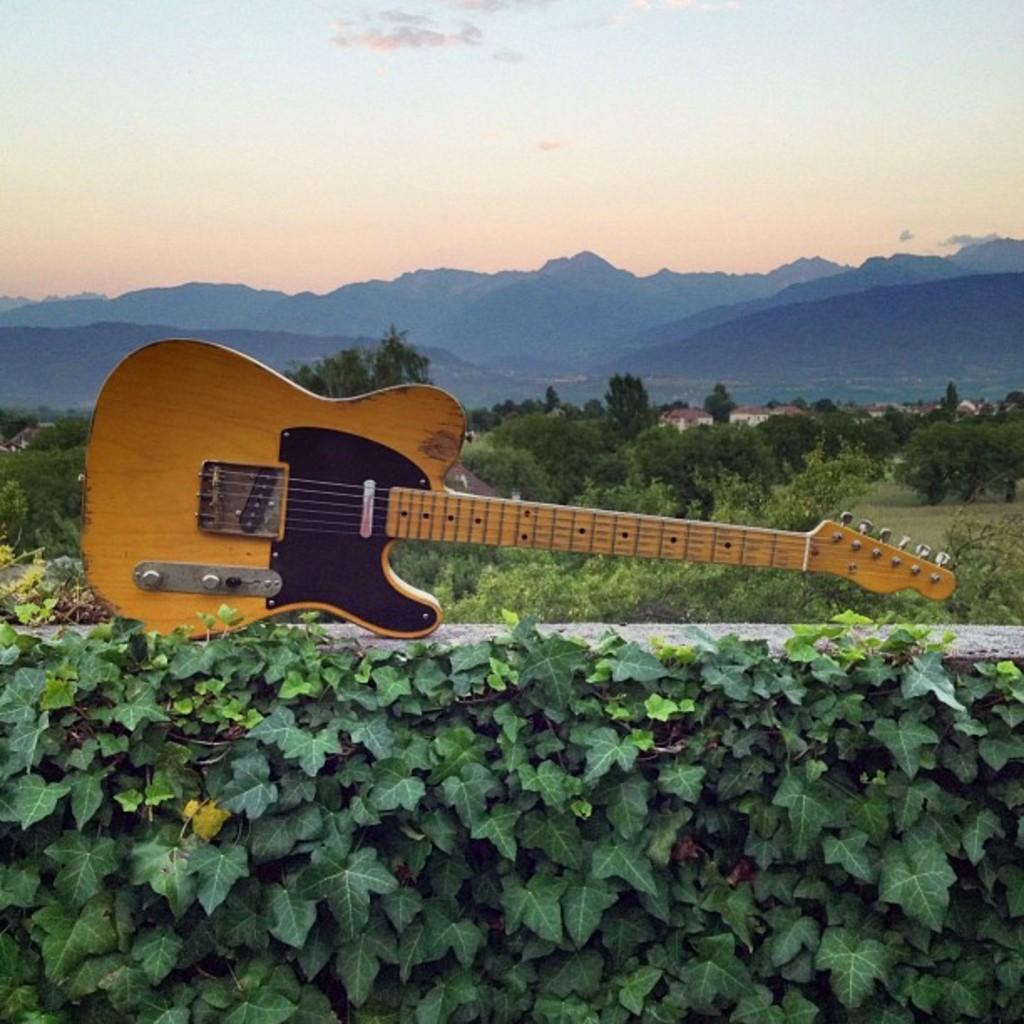What is the main object in the image? There is a guitar in the image. What can be seen in the background of the image? There are trees, mountains, and the sky visible in the background of the image. What type of texture can be seen on the feast in the image? There is no feast present in the image, so it is not possible to determine the texture of any such item. 